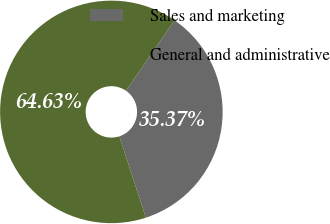<chart> <loc_0><loc_0><loc_500><loc_500><pie_chart><fcel>Sales and marketing<fcel>General and administrative<nl><fcel>35.37%<fcel>64.63%<nl></chart> 